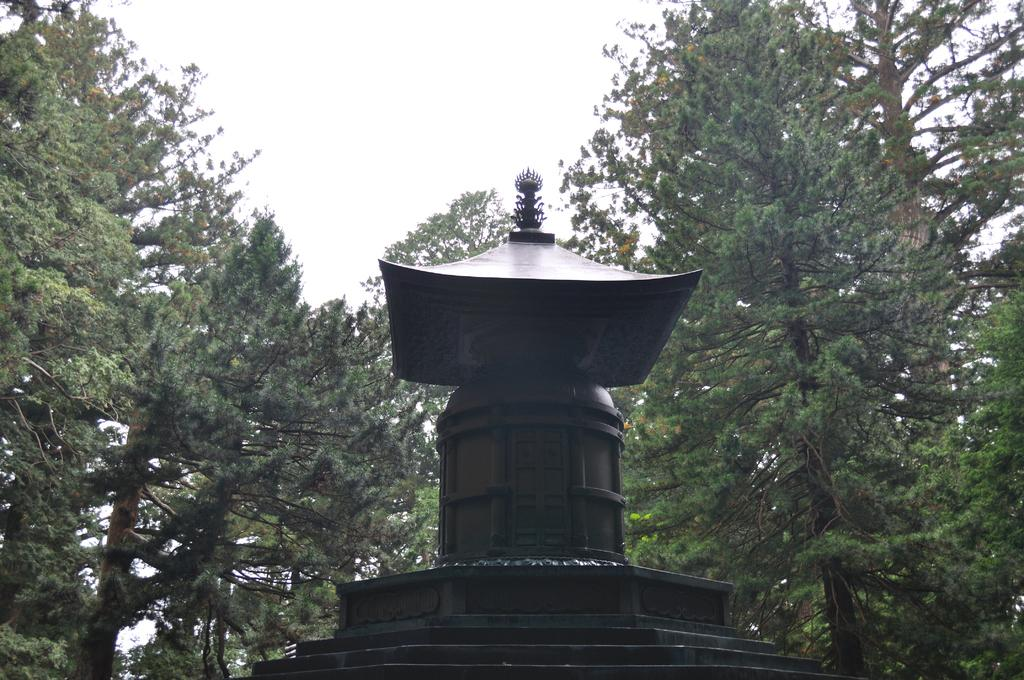What is the main subject in the center of the image? There is a black color memorial in the center of the image. What can be seen in the background of the image? There are trees and the sky visible in the background of the image. How many goldfish are swimming in the memorial in the image? There are no goldfish present in the image, as it features a black color memorial with trees and the sky in the background. 